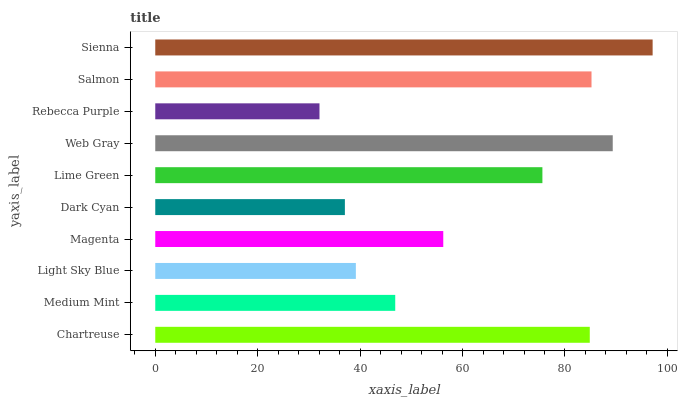Is Rebecca Purple the minimum?
Answer yes or no. Yes. Is Sienna the maximum?
Answer yes or no. Yes. Is Medium Mint the minimum?
Answer yes or no. No. Is Medium Mint the maximum?
Answer yes or no. No. Is Chartreuse greater than Medium Mint?
Answer yes or no. Yes. Is Medium Mint less than Chartreuse?
Answer yes or no. Yes. Is Medium Mint greater than Chartreuse?
Answer yes or no. No. Is Chartreuse less than Medium Mint?
Answer yes or no. No. Is Lime Green the high median?
Answer yes or no. Yes. Is Magenta the low median?
Answer yes or no. Yes. Is Magenta the high median?
Answer yes or no. No. Is Web Gray the low median?
Answer yes or no. No. 